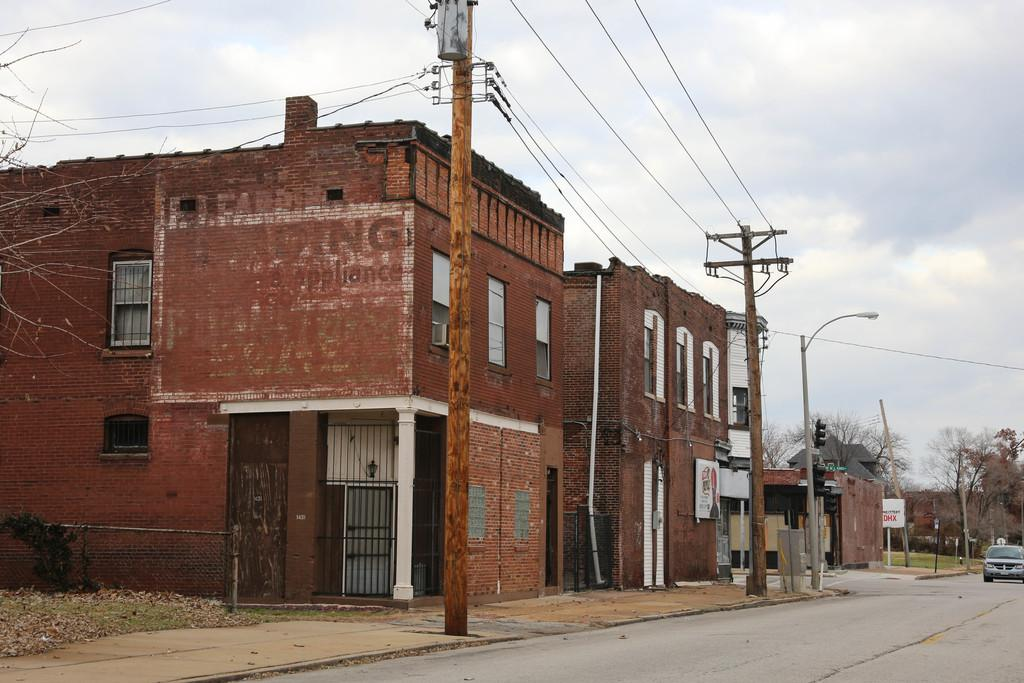What type of structures can be seen in the image? There are buildings in the image. What feature is visible on the buildings? Windows are visible in the image. What type of infrastructure is present in the image? Current poles with wires are present in the image. What traffic control device is attached to a pole? A traffic signal is attached to a pole. What type of vehicle is on the road in the image? There is a car on the road. What type of natural elements can be seen in the background of the image? Trees, grass, and the sky are visible in the background of the image. How many people are in the crowd gathered around the car in the image? There is no crowd present in the image; it only shows a car on the road. What type of wire is used to connect the traffic signal to the pole? The type of wire used to connect the traffic signal to the pole is not visible in the image. What type of cloud formation can be seen in the sky in the image? There is no cloud formation visible in the image; only the sky is visible in the background. 